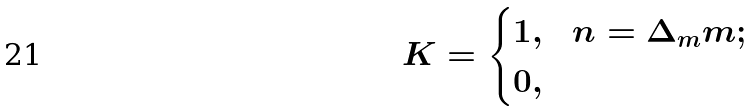Convert formula to latex. <formula><loc_0><loc_0><loc_500><loc_500>K & = \begin{cases} 1 , & n = \Delta _ { m } m ; \\ 0 , & \end{cases}</formula> 